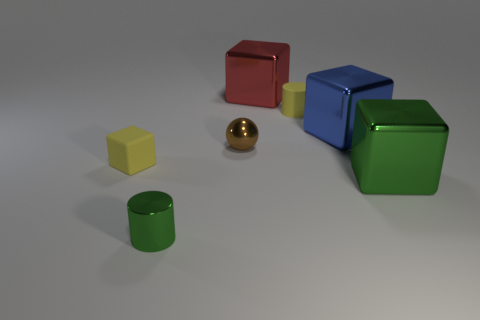Add 2 matte blocks. How many objects exist? 9 Subtract all cyan blocks. Subtract all blue cylinders. How many blocks are left? 4 Subtract all cylinders. How many objects are left? 5 Subtract 0 brown cubes. How many objects are left? 7 Subtract all tiny balls. Subtract all metallic blocks. How many objects are left? 3 Add 2 brown balls. How many brown balls are left? 3 Add 3 metal cubes. How many metal cubes exist? 6 